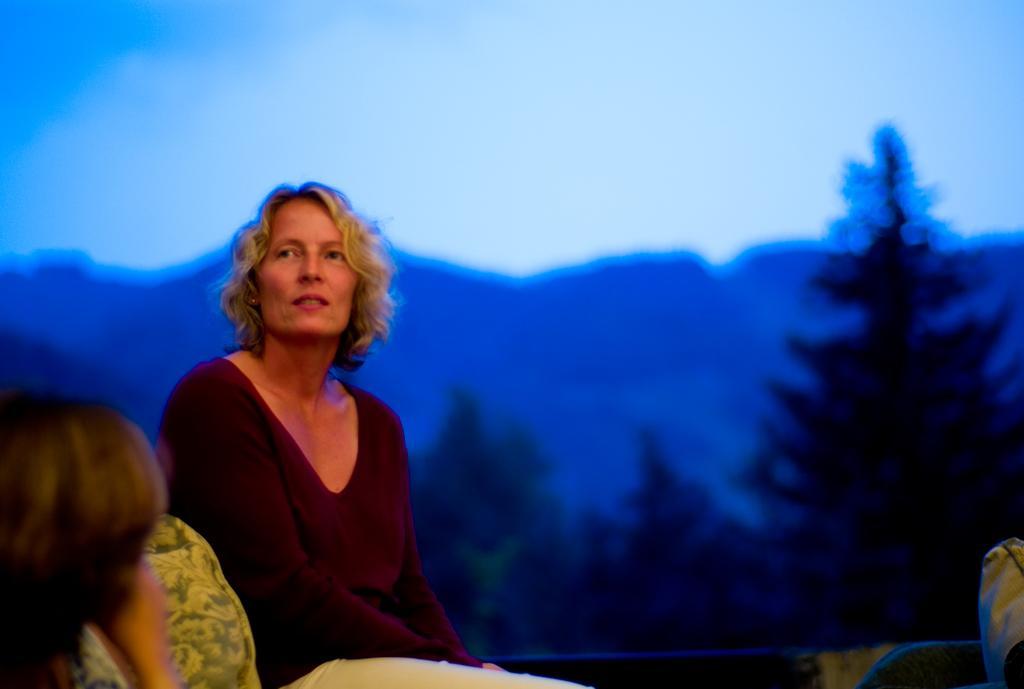Could you give a brief overview of what you see in this image? Here in this picture we can see a woman sitting over a place and in front of her also we can see people sitting and behind her we can see trees and mountains present in a blurry manner over there. 